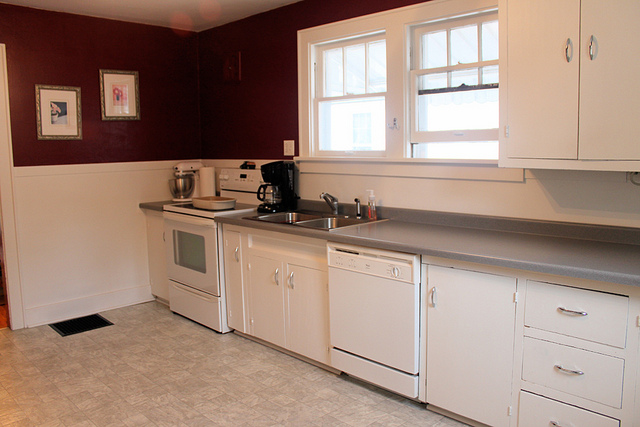Imagine this kitchen is part of a cozy family home. What other rooms might be adjacent to it? Adjacent to this cozy kitchen, one might find a welcoming living room filled with comfortable seating and personal touches such as family photos and a bookshelf. There could also be a dining area, either separate or integrated into an open-plan design, where family meals and gatherings take place. Nearby, a pantry or small laundry area might be tucked away for additional storage and convenience. Picture a dinner party being hosted here. How does the room transform? For a dinner party, the kitchen would transform into a hub of activity and hospitality. The countertops might be cleared of everyday items to make space for platters of appetizers and drinks. Additional lighting, such as candles or string lights, could be added to create a warm and inviting ambiance. The host could be seen bustling around, preparing delicious dishes with the help of a few close friends or family members, while guests gather around to chat and enjoy company. The sound of laughter and clinking glasses would fill the air, making the kitchen the heart of the celebration. 